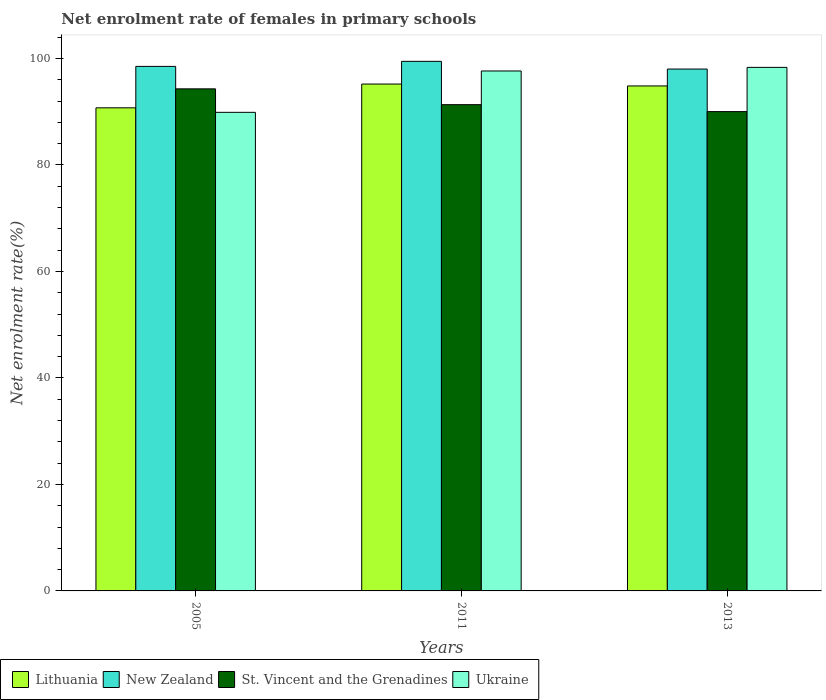How many different coloured bars are there?
Make the answer very short. 4. How many groups of bars are there?
Ensure brevity in your answer.  3. Are the number of bars per tick equal to the number of legend labels?
Your response must be concise. Yes. How many bars are there on the 1st tick from the left?
Keep it short and to the point. 4. How many bars are there on the 3rd tick from the right?
Keep it short and to the point. 4. In how many cases, is the number of bars for a given year not equal to the number of legend labels?
Keep it short and to the point. 0. What is the net enrolment rate of females in primary schools in New Zealand in 2011?
Offer a very short reply. 99.47. Across all years, what is the maximum net enrolment rate of females in primary schools in New Zealand?
Your answer should be very brief. 99.47. Across all years, what is the minimum net enrolment rate of females in primary schools in Lithuania?
Offer a very short reply. 90.74. In which year was the net enrolment rate of females in primary schools in New Zealand minimum?
Make the answer very short. 2013. What is the total net enrolment rate of females in primary schools in Lithuania in the graph?
Provide a short and direct response. 280.79. What is the difference between the net enrolment rate of females in primary schools in Lithuania in 2005 and that in 2013?
Provide a succinct answer. -4.11. What is the difference between the net enrolment rate of females in primary schools in Lithuania in 2005 and the net enrolment rate of females in primary schools in Ukraine in 2013?
Offer a very short reply. -7.59. What is the average net enrolment rate of females in primary schools in St. Vincent and the Grenadines per year?
Your answer should be compact. 91.89. In the year 2011, what is the difference between the net enrolment rate of females in primary schools in St. Vincent and the Grenadines and net enrolment rate of females in primary schools in New Zealand?
Your answer should be very brief. -8.14. What is the ratio of the net enrolment rate of females in primary schools in St. Vincent and the Grenadines in 2005 to that in 2013?
Offer a terse response. 1.05. What is the difference between the highest and the second highest net enrolment rate of females in primary schools in New Zealand?
Provide a short and direct response. 0.95. What is the difference between the highest and the lowest net enrolment rate of females in primary schools in Lithuania?
Your answer should be very brief. 4.47. In how many years, is the net enrolment rate of females in primary schools in St. Vincent and the Grenadines greater than the average net enrolment rate of females in primary schools in St. Vincent and the Grenadines taken over all years?
Keep it short and to the point. 1. Is the sum of the net enrolment rate of females in primary schools in St. Vincent and the Grenadines in 2005 and 2013 greater than the maximum net enrolment rate of females in primary schools in New Zealand across all years?
Your response must be concise. Yes. What does the 4th bar from the left in 2005 represents?
Your response must be concise. Ukraine. What does the 2nd bar from the right in 2005 represents?
Offer a very short reply. St. Vincent and the Grenadines. Is it the case that in every year, the sum of the net enrolment rate of females in primary schools in St. Vincent and the Grenadines and net enrolment rate of females in primary schools in New Zealand is greater than the net enrolment rate of females in primary schools in Lithuania?
Give a very brief answer. Yes. Are all the bars in the graph horizontal?
Offer a terse response. No. Does the graph contain any zero values?
Your answer should be compact. No. Does the graph contain grids?
Offer a terse response. No. Where does the legend appear in the graph?
Give a very brief answer. Bottom left. What is the title of the graph?
Offer a terse response. Net enrolment rate of females in primary schools. Does "Tajikistan" appear as one of the legend labels in the graph?
Keep it short and to the point. No. What is the label or title of the X-axis?
Your answer should be compact. Years. What is the label or title of the Y-axis?
Make the answer very short. Net enrolment rate(%). What is the Net enrolment rate(%) in Lithuania in 2005?
Provide a succinct answer. 90.74. What is the Net enrolment rate(%) in New Zealand in 2005?
Your response must be concise. 98.52. What is the Net enrolment rate(%) of St. Vincent and the Grenadines in 2005?
Keep it short and to the point. 94.3. What is the Net enrolment rate(%) in Ukraine in 2005?
Keep it short and to the point. 89.89. What is the Net enrolment rate(%) in Lithuania in 2011?
Your answer should be very brief. 95.2. What is the Net enrolment rate(%) of New Zealand in 2011?
Your answer should be compact. 99.47. What is the Net enrolment rate(%) in St. Vincent and the Grenadines in 2011?
Your answer should be compact. 91.33. What is the Net enrolment rate(%) in Ukraine in 2011?
Your answer should be very brief. 97.66. What is the Net enrolment rate(%) of Lithuania in 2013?
Make the answer very short. 94.85. What is the Net enrolment rate(%) in New Zealand in 2013?
Your answer should be very brief. 98.02. What is the Net enrolment rate(%) of St. Vincent and the Grenadines in 2013?
Your response must be concise. 90.03. What is the Net enrolment rate(%) in Ukraine in 2013?
Give a very brief answer. 98.33. Across all years, what is the maximum Net enrolment rate(%) in Lithuania?
Ensure brevity in your answer.  95.2. Across all years, what is the maximum Net enrolment rate(%) of New Zealand?
Offer a terse response. 99.47. Across all years, what is the maximum Net enrolment rate(%) of St. Vincent and the Grenadines?
Make the answer very short. 94.3. Across all years, what is the maximum Net enrolment rate(%) of Ukraine?
Provide a short and direct response. 98.33. Across all years, what is the minimum Net enrolment rate(%) in Lithuania?
Provide a succinct answer. 90.74. Across all years, what is the minimum Net enrolment rate(%) in New Zealand?
Provide a succinct answer. 98.02. Across all years, what is the minimum Net enrolment rate(%) in St. Vincent and the Grenadines?
Make the answer very short. 90.03. Across all years, what is the minimum Net enrolment rate(%) in Ukraine?
Your response must be concise. 89.89. What is the total Net enrolment rate(%) in Lithuania in the graph?
Ensure brevity in your answer.  280.79. What is the total Net enrolment rate(%) of New Zealand in the graph?
Keep it short and to the point. 296.01. What is the total Net enrolment rate(%) in St. Vincent and the Grenadines in the graph?
Keep it short and to the point. 275.66. What is the total Net enrolment rate(%) of Ukraine in the graph?
Provide a short and direct response. 285.88. What is the difference between the Net enrolment rate(%) of Lithuania in 2005 and that in 2011?
Your response must be concise. -4.47. What is the difference between the Net enrolment rate(%) of New Zealand in 2005 and that in 2011?
Ensure brevity in your answer.  -0.95. What is the difference between the Net enrolment rate(%) in St. Vincent and the Grenadines in 2005 and that in 2011?
Offer a very short reply. 2.97. What is the difference between the Net enrolment rate(%) of Ukraine in 2005 and that in 2011?
Keep it short and to the point. -7.77. What is the difference between the Net enrolment rate(%) in Lithuania in 2005 and that in 2013?
Give a very brief answer. -4.11. What is the difference between the Net enrolment rate(%) in New Zealand in 2005 and that in 2013?
Keep it short and to the point. 0.5. What is the difference between the Net enrolment rate(%) of St. Vincent and the Grenadines in 2005 and that in 2013?
Your response must be concise. 4.27. What is the difference between the Net enrolment rate(%) in Ukraine in 2005 and that in 2013?
Provide a short and direct response. -8.44. What is the difference between the Net enrolment rate(%) in Lithuania in 2011 and that in 2013?
Provide a short and direct response. 0.36. What is the difference between the Net enrolment rate(%) in New Zealand in 2011 and that in 2013?
Ensure brevity in your answer.  1.45. What is the difference between the Net enrolment rate(%) in St. Vincent and the Grenadines in 2011 and that in 2013?
Give a very brief answer. 1.3. What is the difference between the Net enrolment rate(%) of Ukraine in 2011 and that in 2013?
Offer a very short reply. -0.67. What is the difference between the Net enrolment rate(%) in Lithuania in 2005 and the Net enrolment rate(%) in New Zealand in 2011?
Give a very brief answer. -8.73. What is the difference between the Net enrolment rate(%) in Lithuania in 2005 and the Net enrolment rate(%) in St. Vincent and the Grenadines in 2011?
Offer a terse response. -0.59. What is the difference between the Net enrolment rate(%) in Lithuania in 2005 and the Net enrolment rate(%) in Ukraine in 2011?
Give a very brief answer. -6.92. What is the difference between the Net enrolment rate(%) in New Zealand in 2005 and the Net enrolment rate(%) in St. Vincent and the Grenadines in 2011?
Provide a short and direct response. 7.19. What is the difference between the Net enrolment rate(%) in New Zealand in 2005 and the Net enrolment rate(%) in Ukraine in 2011?
Ensure brevity in your answer.  0.86. What is the difference between the Net enrolment rate(%) in St. Vincent and the Grenadines in 2005 and the Net enrolment rate(%) in Ukraine in 2011?
Provide a short and direct response. -3.36. What is the difference between the Net enrolment rate(%) of Lithuania in 2005 and the Net enrolment rate(%) of New Zealand in 2013?
Keep it short and to the point. -7.28. What is the difference between the Net enrolment rate(%) in Lithuania in 2005 and the Net enrolment rate(%) in St. Vincent and the Grenadines in 2013?
Provide a succinct answer. 0.71. What is the difference between the Net enrolment rate(%) of Lithuania in 2005 and the Net enrolment rate(%) of Ukraine in 2013?
Your answer should be very brief. -7.59. What is the difference between the Net enrolment rate(%) in New Zealand in 2005 and the Net enrolment rate(%) in St. Vincent and the Grenadines in 2013?
Keep it short and to the point. 8.49. What is the difference between the Net enrolment rate(%) in New Zealand in 2005 and the Net enrolment rate(%) in Ukraine in 2013?
Provide a short and direct response. 0.19. What is the difference between the Net enrolment rate(%) in St. Vincent and the Grenadines in 2005 and the Net enrolment rate(%) in Ukraine in 2013?
Your answer should be compact. -4.03. What is the difference between the Net enrolment rate(%) in Lithuania in 2011 and the Net enrolment rate(%) in New Zealand in 2013?
Provide a succinct answer. -2.82. What is the difference between the Net enrolment rate(%) of Lithuania in 2011 and the Net enrolment rate(%) of St. Vincent and the Grenadines in 2013?
Make the answer very short. 5.17. What is the difference between the Net enrolment rate(%) of Lithuania in 2011 and the Net enrolment rate(%) of Ukraine in 2013?
Make the answer very short. -3.13. What is the difference between the Net enrolment rate(%) of New Zealand in 2011 and the Net enrolment rate(%) of St. Vincent and the Grenadines in 2013?
Your response must be concise. 9.44. What is the difference between the Net enrolment rate(%) of New Zealand in 2011 and the Net enrolment rate(%) of Ukraine in 2013?
Keep it short and to the point. 1.13. What is the difference between the Net enrolment rate(%) in St. Vincent and the Grenadines in 2011 and the Net enrolment rate(%) in Ukraine in 2013?
Offer a terse response. -7. What is the average Net enrolment rate(%) in Lithuania per year?
Your answer should be very brief. 93.6. What is the average Net enrolment rate(%) in New Zealand per year?
Give a very brief answer. 98.67. What is the average Net enrolment rate(%) of St. Vincent and the Grenadines per year?
Make the answer very short. 91.89. What is the average Net enrolment rate(%) in Ukraine per year?
Offer a very short reply. 95.29. In the year 2005, what is the difference between the Net enrolment rate(%) in Lithuania and Net enrolment rate(%) in New Zealand?
Offer a terse response. -7.78. In the year 2005, what is the difference between the Net enrolment rate(%) in Lithuania and Net enrolment rate(%) in St. Vincent and the Grenadines?
Give a very brief answer. -3.56. In the year 2005, what is the difference between the Net enrolment rate(%) of Lithuania and Net enrolment rate(%) of Ukraine?
Your answer should be compact. 0.85. In the year 2005, what is the difference between the Net enrolment rate(%) of New Zealand and Net enrolment rate(%) of St. Vincent and the Grenadines?
Ensure brevity in your answer.  4.22. In the year 2005, what is the difference between the Net enrolment rate(%) of New Zealand and Net enrolment rate(%) of Ukraine?
Provide a succinct answer. 8.63. In the year 2005, what is the difference between the Net enrolment rate(%) in St. Vincent and the Grenadines and Net enrolment rate(%) in Ukraine?
Keep it short and to the point. 4.41. In the year 2011, what is the difference between the Net enrolment rate(%) of Lithuania and Net enrolment rate(%) of New Zealand?
Offer a very short reply. -4.26. In the year 2011, what is the difference between the Net enrolment rate(%) of Lithuania and Net enrolment rate(%) of St. Vincent and the Grenadines?
Provide a succinct answer. 3.87. In the year 2011, what is the difference between the Net enrolment rate(%) in Lithuania and Net enrolment rate(%) in Ukraine?
Provide a succinct answer. -2.46. In the year 2011, what is the difference between the Net enrolment rate(%) in New Zealand and Net enrolment rate(%) in St. Vincent and the Grenadines?
Provide a succinct answer. 8.14. In the year 2011, what is the difference between the Net enrolment rate(%) in New Zealand and Net enrolment rate(%) in Ukraine?
Keep it short and to the point. 1.81. In the year 2011, what is the difference between the Net enrolment rate(%) of St. Vincent and the Grenadines and Net enrolment rate(%) of Ukraine?
Provide a short and direct response. -6.33. In the year 2013, what is the difference between the Net enrolment rate(%) of Lithuania and Net enrolment rate(%) of New Zealand?
Provide a short and direct response. -3.17. In the year 2013, what is the difference between the Net enrolment rate(%) in Lithuania and Net enrolment rate(%) in St. Vincent and the Grenadines?
Your response must be concise. 4.82. In the year 2013, what is the difference between the Net enrolment rate(%) of Lithuania and Net enrolment rate(%) of Ukraine?
Keep it short and to the point. -3.49. In the year 2013, what is the difference between the Net enrolment rate(%) of New Zealand and Net enrolment rate(%) of St. Vincent and the Grenadines?
Make the answer very short. 7.99. In the year 2013, what is the difference between the Net enrolment rate(%) in New Zealand and Net enrolment rate(%) in Ukraine?
Give a very brief answer. -0.31. In the year 2013, what is the difference between the Net enrolment rate(%) of St. Vincent and the Grenadines and Net enrolment rate(%) of Ukraine?
Your response must be concise. -8.3. What is the ratio of the Net enrolment rate(%) of Lithuania in 2005 to that in 2011?
Make the answer very short. 0.95. What is the ratio of the Net enrolment rate(%) of New Zealand in 2005 to that in 2011?
Your answer should be compact. 0.99. What is the ratio of the Net enrolment rate(%) in St. Vincent and the Grenadines in 2005 to that in 2011?
Offer a very short reply. 1.03. What is the ratio of the Net enrolment rate(%) of Ukraine in 2005 to that in 2011?
Your response must be concise. 0.92. What is the ratio of the Net enrolment rate(%) of Lithuania in 2005 to that in 2013?
Your answer should be compact. 0.96. What is the ratio of the Net enrolment rate(%) of New Zealand in 2005 to that in 2013?
Your response must be concise. 1.01. What is the ratio of the Net enrolment rate(%) of St. Vincent and the Grenadines in 2005 to that in 2013?
Provide a succinct answer. 1.05. What is the ratio of the Net enrolment rate(%) of Ukraine in 2005 to that in 2013?
Your answer should be very brief. 0.91. What is the ratio of the Net enrolment rate(%) in Lithuania in 2011 to that in 2013?
Your response must be concise. 1. What is the ratio of the Net enrolment rate(%) in New Zealand in 2011 to that in 2013?
Your answer should be very brief. 1.01. What is the ratio of the Net enrolment rate(%) in St. Vincent and the Grenadines in 2011 to that in 2013?
Ensure brevity in your answer.  1.01. What is the difference between the highest and the second highest Net enrolment rate(%) in Lithuania?
Give a very brief answer. 0.36. What is the difference between the highest and the second highest Net enrolment rate(%) in New Zealand?
Provide a short and direct response. 0.95. What is the difference between the highest and the second highest Net enrolment rate(%) in St. Vincent and the Grenadines?
Offer a very short reply. 2.97. What is the difference between the highest and the second highest Net enrolment rate(%) of Ukraine?
Your response must be concise. 0.67. What is the difference between the highest and the lowest Net enrolment rate(%) of Lithuania?
Give a very brief answer. 4.47. What is the difference between the highest and the lowest Net enrolment rate(%) of New Zealand?
Your response must be concise. 1.45. What is the difference between the highest and the lowest Net enrolment rate(%) of St. Vincent and the Grenadines?
Provide a succinct answer. 4.27. What is the difference between the highest and the lowest Net enrolment rate(%) of Ukraine?
Ensure brevity in your answer.  8.44. 